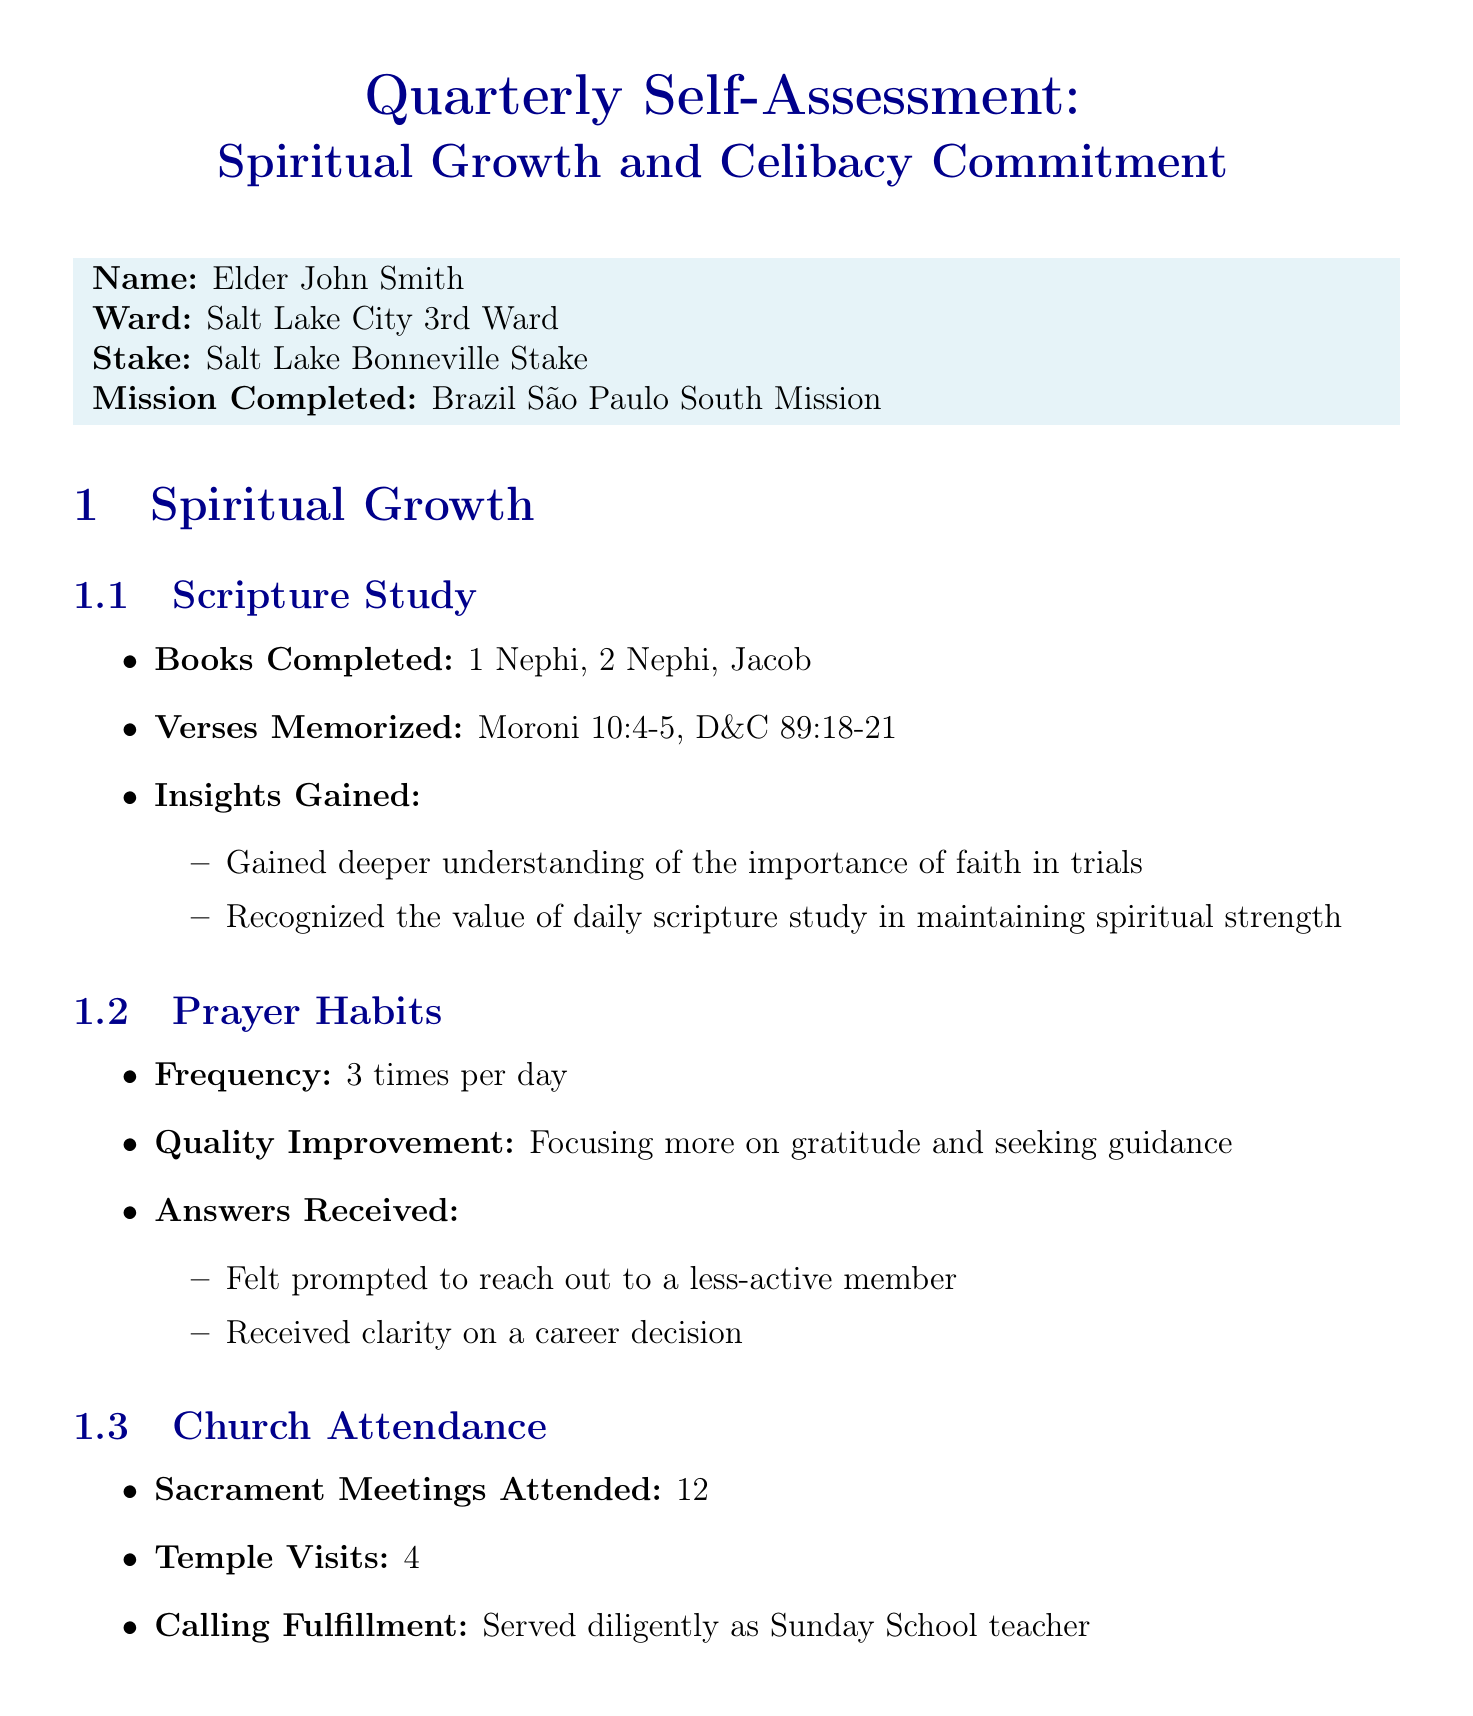What is the name of the individual? The report identifies the individual as Elder John Smith.
Answer: Elder John Smith How many verses has he memorized? The report specifies that two verses have been memorized, which are Moroni 10:4-5 and D&C 89:18-21.
Answer: 2 What are the total sacrament meetings attended? The document states that 12 sacrament meetings were attended.
Answer: 12 What is one coping strategy mentioned? One of the coping strategies listed is increased involvement in ward activities.
Answer: Increased involvement in ward activities What spiritual goal is set for the next quarter? The individual aims to complete the reading of the Book of Mormon by the next quarter as a spiritual goal.
Answer: Complete reading of the Book of Mormon by next quarter What is one strength identified in the personal reflection? The report highlights consistency in daily prayer as one of the strengths identified.
Answer: Consistency in daily prayer What pressure does the individual face regarding celibacy? The individual faces pressure from non-member friends to date as a challenge to maintaining celibacy.
Answer: Pressure from non-member friends to date How many temple visits were recorded? The total number of temple visits recorded in the report is 4.
Answer: 4 What is the purpose of this document? The purpose of the document is to provide a self-assessment of spiritual growth and commitment to celibacy.
Answer: Self-assessment of spiritual growth and celibacy commitment 